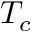<formula> <loc_0><loc_0><loc_500><loc_500>T _ { c }</formula> 